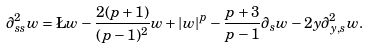<formula> <loc_0><loc_0><loc_500><loc_500>\partial ^ { 2 } _ { s s } w = \L w - \frac { 2 ( p + 1 ) } { ( p - 1 ) ^ { 2 } } w + | w | ^ { p } - \frac { p + 3 } { p - 1 } \partial _ { s } w - 2 y \partial ^ { 2 } _ { y , s } w .</formula> 